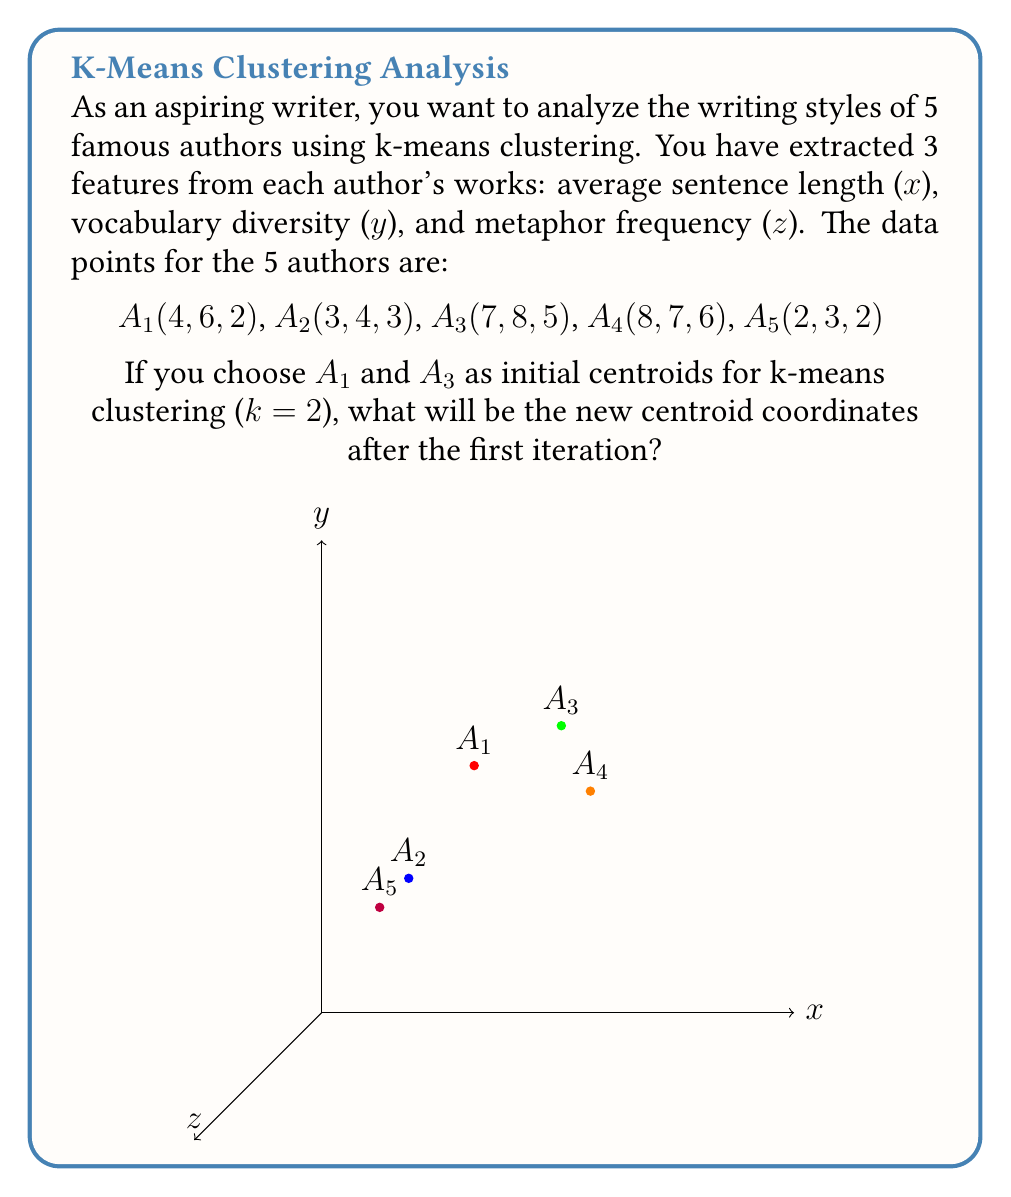Teach me how to tackle this problem. Let's approach this step-by-step:

1) Initially, we have two centroids:
   C1 = A1(4, 6, 2)
   C2 = A3(7, 8, 5)

2) We need to assign each point to the nearest centroid. We can do this by calculating the Euclidean distance from each point to both centroids.

3) For each point A(x, y, z), the distance to a centroid C(cx, cy, cz) is given by:
   $$d = \sqrt{(x-cx)^2 + (y-cy)^2 + (z-cz)^2}$$

4) Let's calculate these distances:

   A2 to C1: $\sqrt{(3-4)^2 + (4-6)^2 + (3-2)^2} = \sqrt{1 + 4 + 1} = \sqrt{6} \approx 2.45$
   A2 to C2: $\sqrt{(3-7)^2 + (4-8)^2 + (3-5)^2} = \sqrt{16 + 16 + 4} = 6$
   A2 is closer to C1

   A4 to C1: $\sqrt{(8-4)^2 + (7-6)^2 + (6-2)^2} = \sqrt{16 + 1 + 16} = \sqrt{33} \approx 5.74$
   A4 to C2: $\sqrt{(8-7)^2 + (7-8)^2 + (6-5)^2} = \sqrt{1 + 1 + 1} = \sqrt{3} \approx 1.73$
   A4 is closer to C2

   A5 to C1: $\sqrt{(2-4)^2 + (3-6)^2 + (2-2)^2} = \sqrt{4 + 9 + 0} = \sqrt{13} \approx 3.61$
   A5 to C2: $\sqrt{(2-7)^2 + (3-8)^2 + (2-5)^2} = \sqrt{25 + 25 + 9} = \sqrt{59} \approx 7.68$
   A5 is closer to C1

5) So, we have two clusters:
   Cluster 1: A1, A2, A5
   Cluster 2: A3, A4

6) The new centroids are the average of the points in each cluster:

   New C1 = $(\frac{4+3+2}{3}, \frac{6+4+3}{3}, \frac{2+3+2}{3}) = (3, 4.33, 2.33)$
   New C2 = $(\frac{7+8}{2}, \frac{8+7}{2}, \frac{5+6}{2}) = (7.5, 7.5, 5.5)$

Therefore, the new centroid coordinates after the first iteration are:
C1(3, 4.33, 2.33) and C2(7.5, 7.5, 5.5)
Answer: C1(3, 4.33, 2.33), C2(7.5, 7.5, 5.5) 